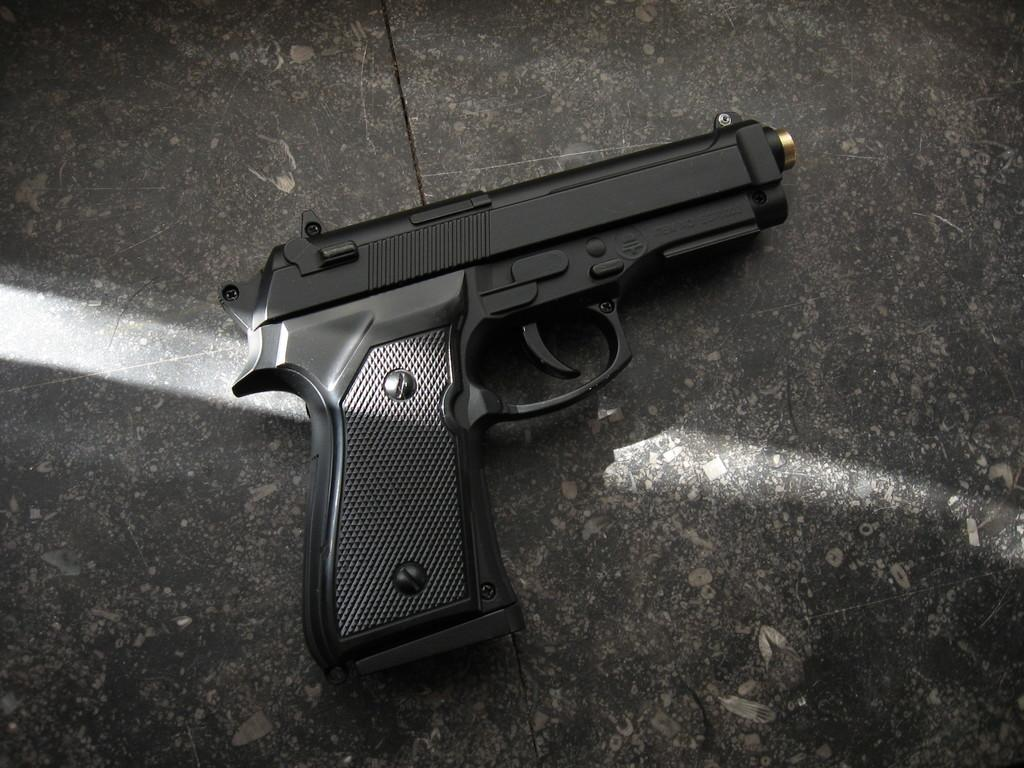What object is the main focus of the image? There is a gun in the image. Where is the gun located? The gun is on a platform. What type of news is being reported by the person wearing a skirt in the image? There is no person wearing a skirt or any news reporting present in the image; it only features a gun on a platform. 